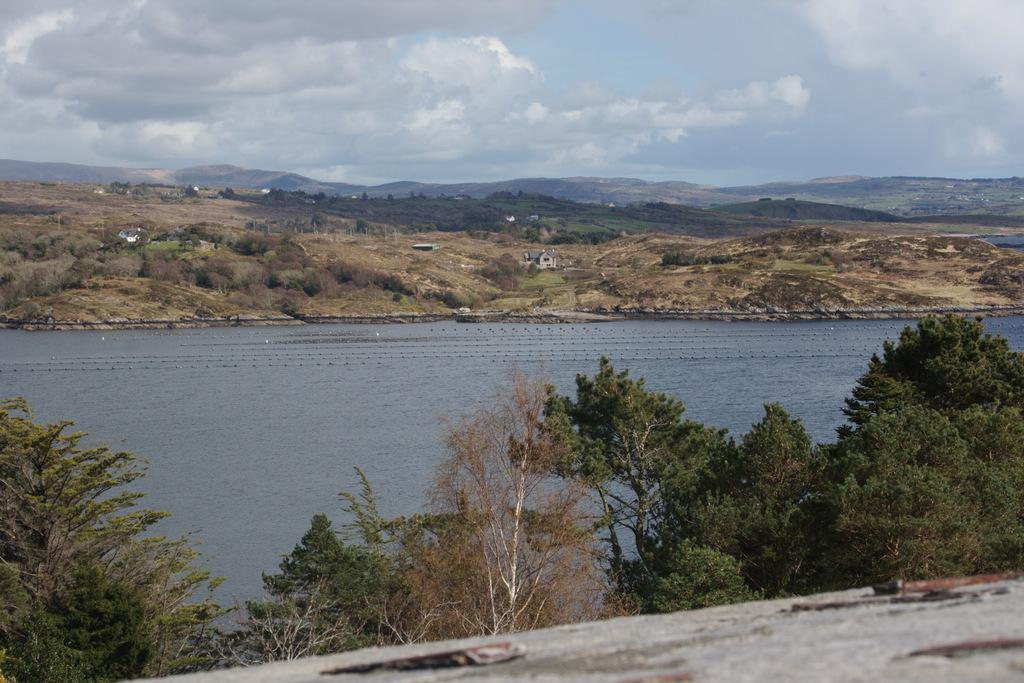What type of vegetation is present in the image? There are trees in the image. What color are the trees? The trees are green. What can be seen in the background of the image? There is water, houses, and the sky visible in the background of the image. How would you describe the color of the sky in the image? The sky is visible in the background of the image, with a combination of white and blue colors. How many needles are sticking out of the trees in the image? There are no needles present in the image; the trees are green and leafy. What type of sticks can be seen in the image? There are no sticks visible in the image; the focus is on the trees, water, houses, and sky. 